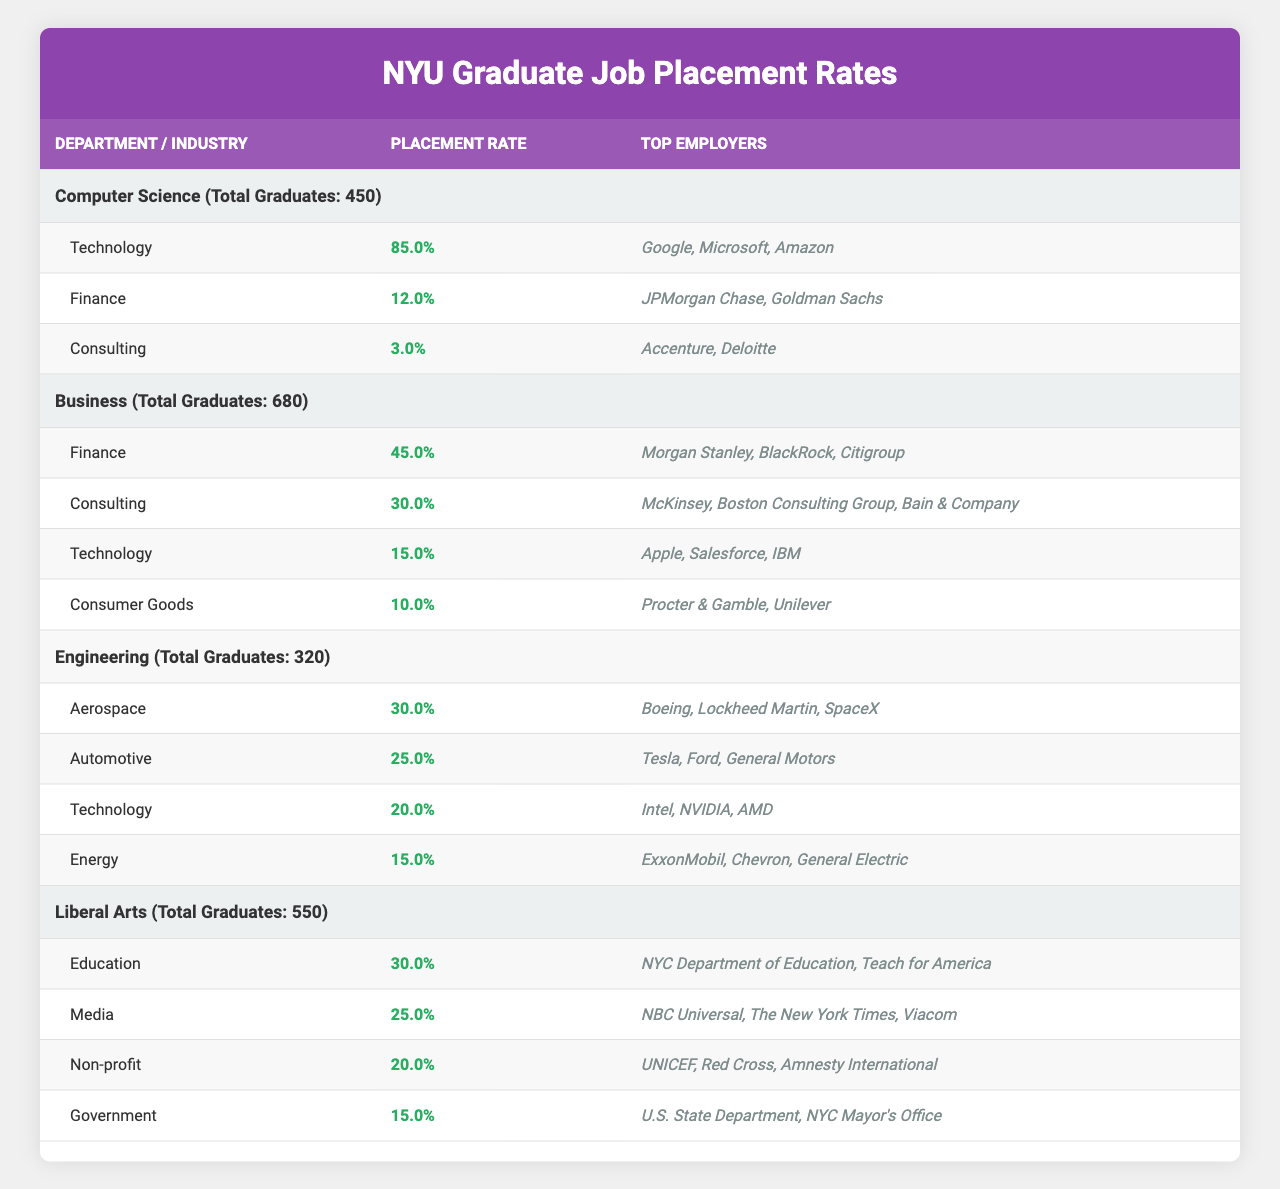What is the placement rate for Computer Science graduates in the Technology industry? According to the table, the Computer Science department has a placement rate of 85% specifically for the Technology industry.
Answer: 85% Which academic department has the highest placement rate in the Finance industry? The Business department has the highest placement rate in the Finance industry at 45%, compared to 12% in Computer Science.
Answer: Business How many total graduates are there in the Engineering department? The table states that the Engineering department has a total of 320 graduates.
Answer: 320 What are the top employers for Liberal Arts graduates in the Media industry? The top employers listed for the Liberal Arts graduates in the Media industry are NBC Universal, The New York Times, and Viacom.
Answer: NBC Universal, The New York Times, Viacom Calculate the average placement rate for the Consulting industry across all departments. The placement rates for Consulting are 3% (Computer Science), 30% (Business), and 20% (Liberal Arts). The average is (3 + 30 + 20) / 3 = 53 / 3 = 17.67%.
Answer: 17.7% Is there a department that has a higher placement rate in the Technology industry compared to the Automotive industry? Yes, the Computer Science department has a Technology placement rate of 85%, which is higher than the Automotive industry's 25% in Engineering.
Answer: Yes What percentage of graduates from the Business department are placed in the Consumer Goods industry? The Consumer Goods industry has a placement rate of 10% for Business graduates, which means 68 graduates in total would be placed there (68 = 0.10 * 680).
Answer: 10% Identify the industry with the lowest placement rate for graduates from the Engineering department. The Engineering department has the lowest placement rate in the Aerospace industry at 30% compared to other industries mentioned in that department.
Answer: Aerospace How many total top employers are listed for the Finance industry across all departments? The top employers for Finance are 2 for Computer Science (JPMorgan Chase, Goldman Sachs) and 3 for Business (Morgan Stanley, BlackRock, Citigroup). So, total unique top employers are 5.
Answer: 5 Which department has the highest number of total graduates and what is that number? The Business department has the highest total number of graduates with 680 graduates.
Answer: 680 What is the placement rate for the Non-profit sector in the Liberal Arts department? The placement rate for the Non-profit sector for Liberal Arts graduates is 20%.
Answer: 20% 